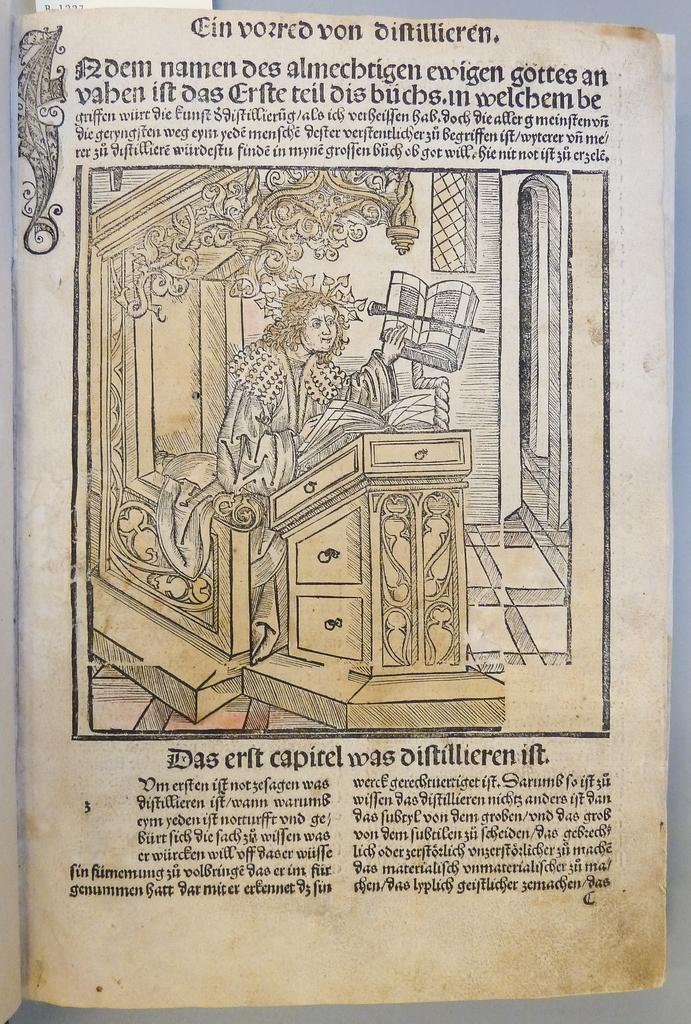What is the person in the image doing? There is a person sitting in the image. What can be seen in front of the person? There are objects in front of the person. What can be seen beside the person? There are objects beside the person. What is written above the image? There is text written above the image. What is written below the image? There is text written below the image. What type of acoustics can be heard in the image? There is no information about acoustics or sound in the image, as it only shows a person sitting with objects around them and text above and below. Can you see a pickle in the image? There is no mention of a pickle or any food item in the image. 